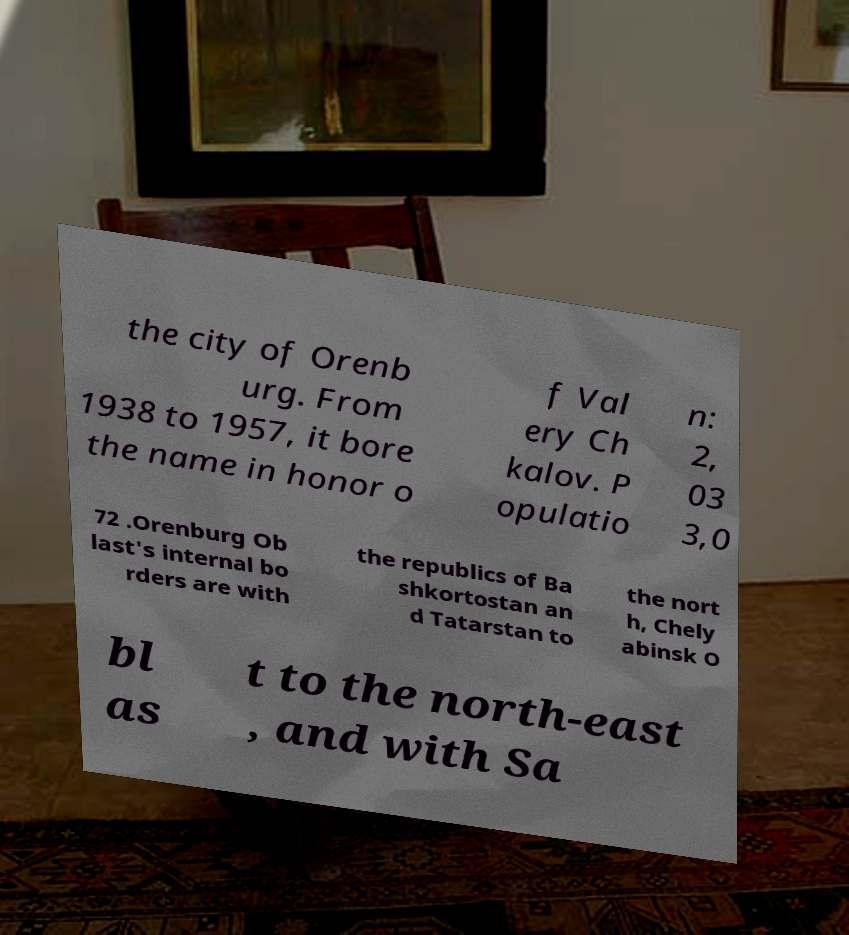Could you extract and type out the text from this image? the city of Orenb urg. From 1938 to 1957, it bore the name in honor o f Val ery Ch kalov. P opulatio n: 2, 03 3,0 72 .Orenburg Ob last's internal bo rders are with the republics of Ba shkortostan an d Tatarstan to the nort h, Chely abinsk O bl as t to the north-east , and with Sa 